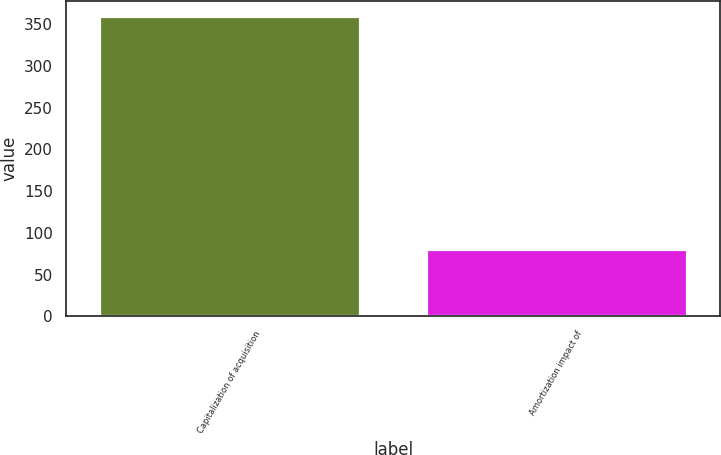<chart> <loc_0><loc_0><loc_500><loc_500><bar_chart><fcel>Capitalization of acquisition<fcel>Amortization impact of<nl><fcel>360<fcel>81<nl></chart> 